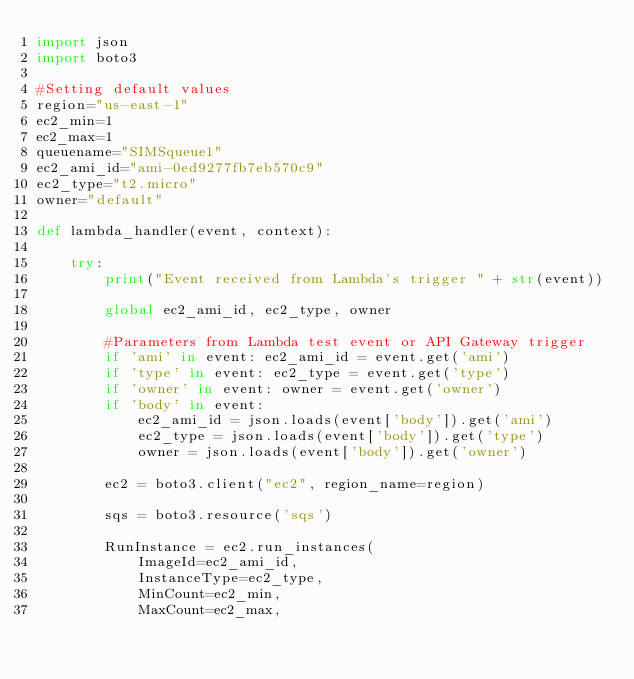Convert code to text. <code><loc_0><loc_0><loc_500><loc_500><_Python_>import json
import boto3

#Setting default values
region="us-east-1"
ec2_min=1
ec2_max=1
queuename="SIMSqueue1"
ec2_ami_id="ami-0ed9277fb7eb570c9"
ec2_type="t2.micro"
owner="default"

def lambda_handler(event, context):
    
    try:
        print("Event received from Lambda's trigger " + str(event))
        
        global ec2_ami_id, ec2_type, owner
            
        #Parameters from Lambda test event or API Gateway trigger
        if 'ami' in event: ec2_ami_id = event.get('ami')
        if 'type' in event: ec2_type = event.get('type')
        if 'owner' in event: owner = event.get('owner')
        if 'body' in event: 
            ec2_ami_id = json.loads(event['body']).get('ami')
            ec2_type = json.loads(event['body']).get('type')
            owner = json.loads(event['body']).get('owner')
        
        ec2 = boto3.client("ec2", region_name=region)
        
        sqs = boto3.resource('sqs')
        
        RunInstance = ec2.run_instances(
            ImageId=ec2_ami_id,
            InstanceType=ec2_type,
            MinCount=ec2_min,
            MaxCount=ec2_max,</code> 